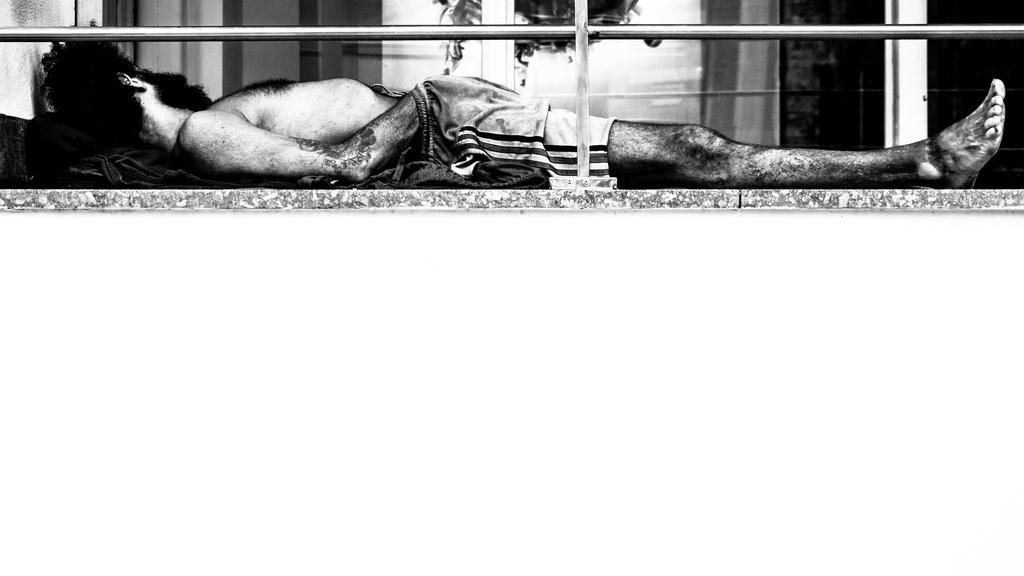Please provide a concise description of this image. This image is a black and white image. This image is taken outdoors. At the bottom of the image there is a floor. In the middle of the image a man is lying on the floor and there is a railing. In the background there is a wall. 